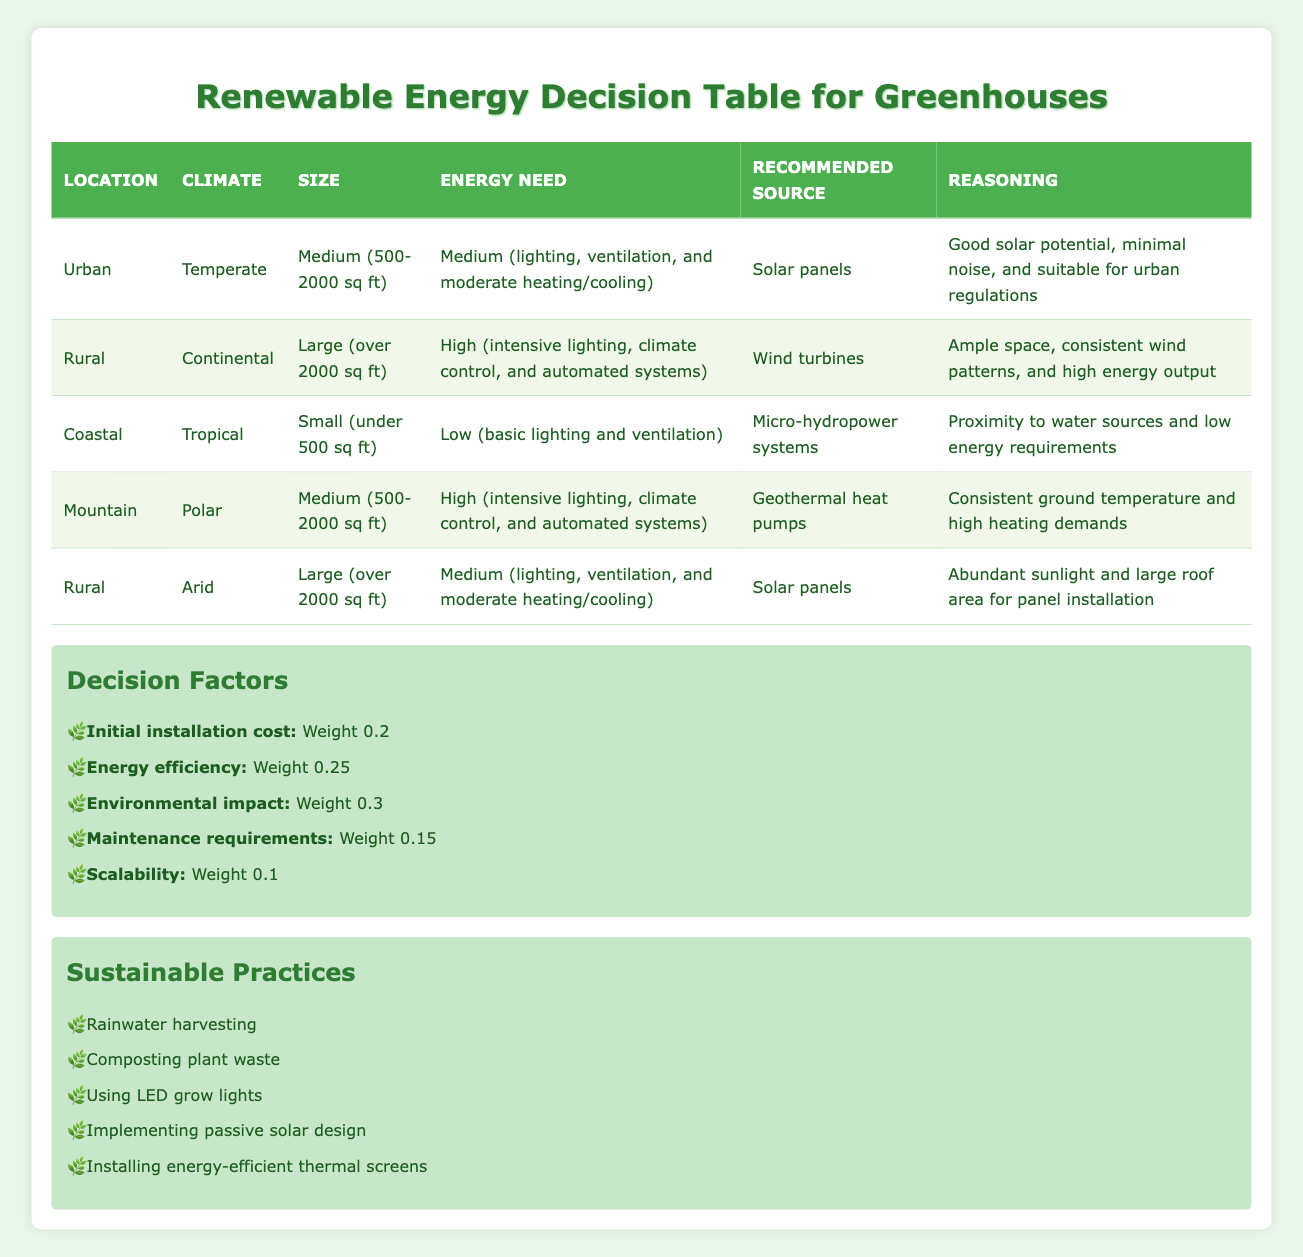What is the recommended energy source for a greenhouse located in an urban area with a temperate climate and medium energy needs? The table shows that for the location "Urban," climate "Temperate," size "Medium (500-2000 sq ft)," and energy need "Medium (lighting, ventilation, and moderate heating/cooling)," the recommended energy source is "Solar panels."
Answer: Solar panels Which renewable energy source is suggested for a large rural greenhouse in a continental climate with high energy needs? According to the table, for the location "Rural," climate "Continental," size "Large (over 2000 sq ft)," and energy need "High (intensive lighting, climate control, and automated systems)," the recommended energy source is "Wind turbines."
Answer: Wind turbines True or False: Micro-hydropower systems are recommended for small greenhouses in coastal tropical climates. The table indicates that micro-hydropower systems are suitable for the location "Coastal," climate "Tropical," size "Small (under 500 sq ft)," and energy need "Low (basic lighting and ventilation)," thus the statement is true.
Answer: True If a rural greenhouse has medium energy needs and is located in an arid climate, what is the recommended energy source? The table specifies that for a "Rural," "Arid" climate greenhouse with "Medium (lighting, ventilation, and moderate heating/cooling)" energy needs, the recommended energy source is "Solar panels." The reasoning is based on abundant sunlight and roof area for installation.
Answer: Solar panels What is the total number of renewable energy sources recommended across all scenarios presented in the table? By examining the table, we see that there are 5 unique scenarios listed, each recommending one specific renewable energy source: solar panels, wind turbines, micro-hydropower systems, and geothermal heat pumps. Therefore, the total number of different recommended sources is 4.
Answer: 4 What are the environmental impacts of using wind turbines compared to geothermal heat pumps for greenhouses? The table does not explicitly list detailed environmental impacts in comparison; however, it states the recommended use of wind turbines for large rural greenhouses with high energy needs, while geothermal heat pumps are recommended for medium-sized mountaineous greenhouses with high needs as well. Both sources are environmentally beneficial but may have different impacts based on location.
Answer: Varies (not directly specified) How many renewable energy sources are recommended for high energy needs in the table? There are two scenarios with a high energy need in the table: the rural continental greenhouse recommended wind turbines and the mountain polar greenhouse advised to use geothermal heat pumps. Therefore, the number of renewable energy sources recommended for high energy needs is 2.
Answer: 2 Given the decision factors, which one has the highest weight? By observing the decision factors listed in the table, the factor with the highest weight is "Environmental impact," which has a weight of 0.3.
Answer: Environmental impact 